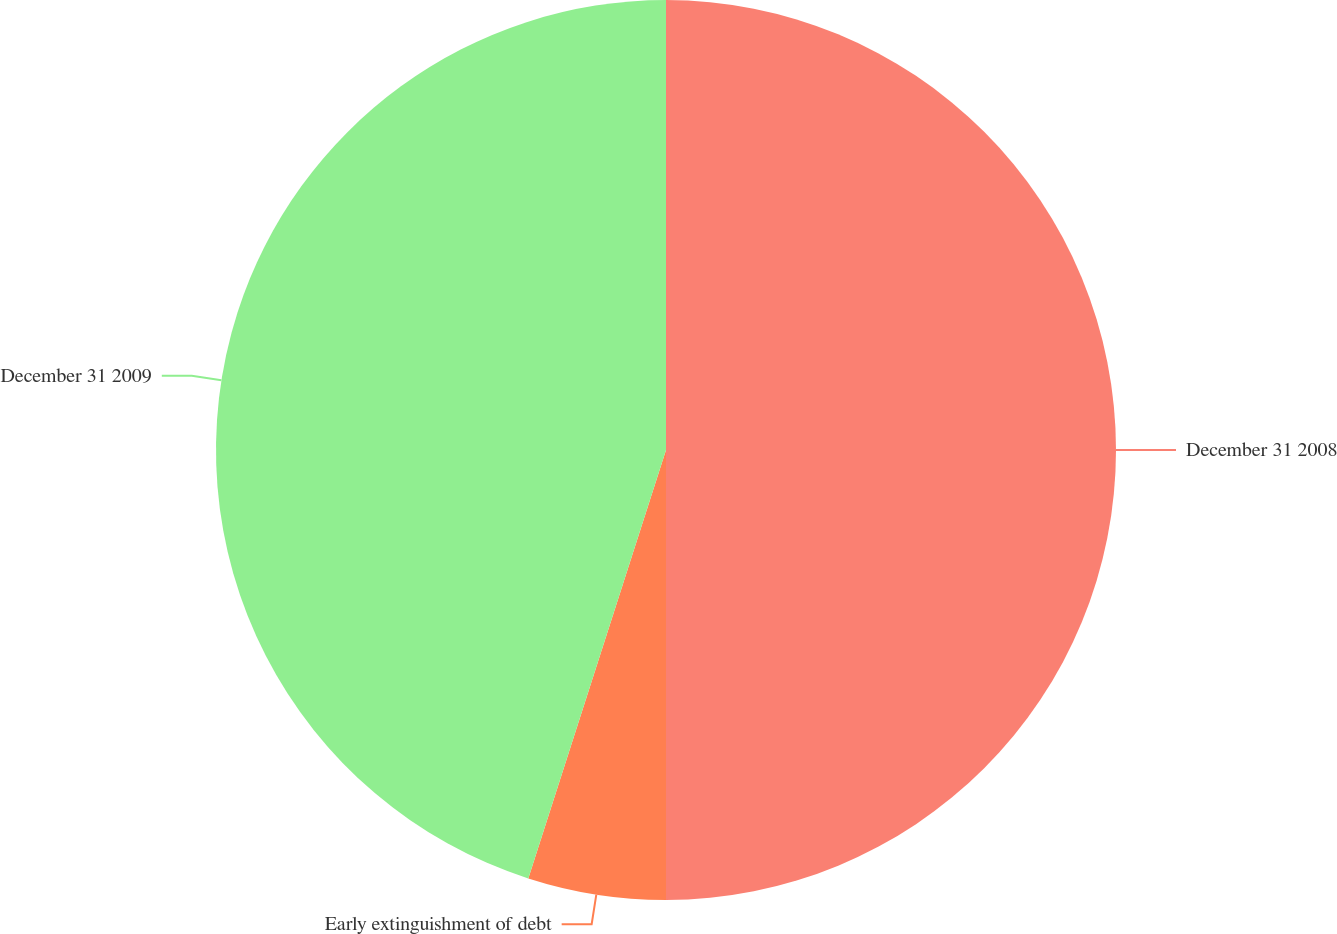<chart> <loc_0><loc_0><loc_500><loc_500><pie_chart><fcel>December 31 2008<fcel>Early extinguishment of debt<fcel>December 31 2009<nl><fcel>50.0%<fcel>4.95%<fcel>45.05%<nl></chart> 